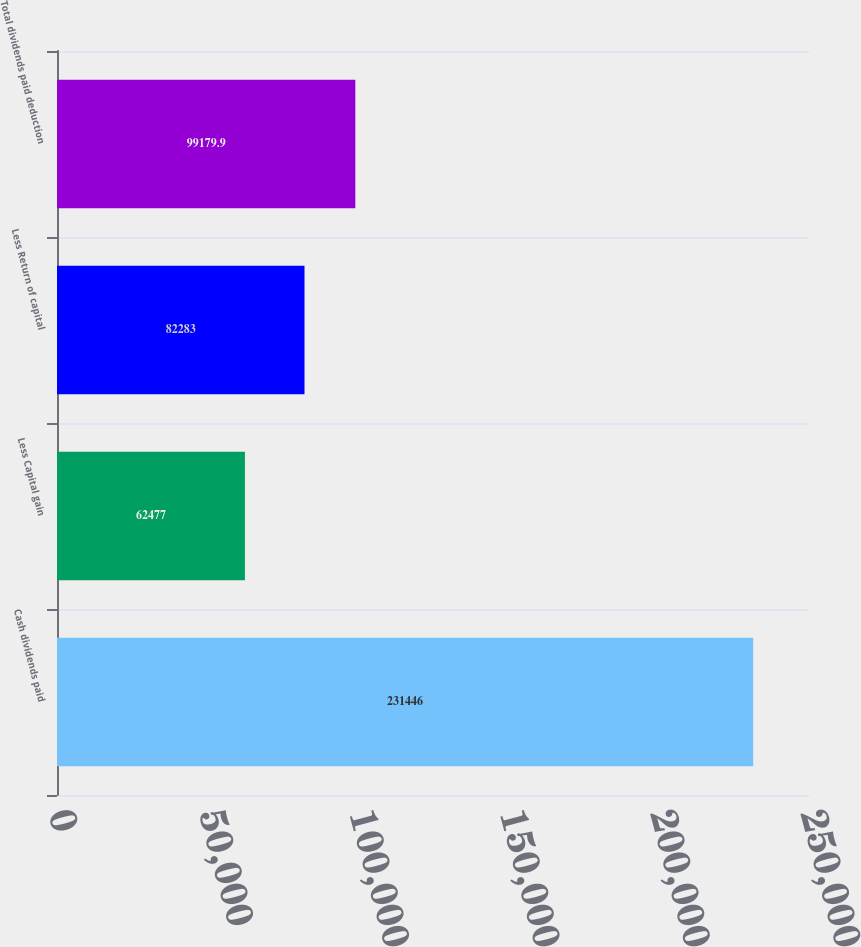Convert chart. <chart><loc_0><loc_0><loc_500><loc_500><bar_chart><fcel>Cash dividends paid<fcel>Less Capital gain<fcel>Less Return of capital<fcel>Total dividends paid deduction<nl><fcel>231446<fcel>62477<fcel>82283<fcel>99179.9<nl></chart> 